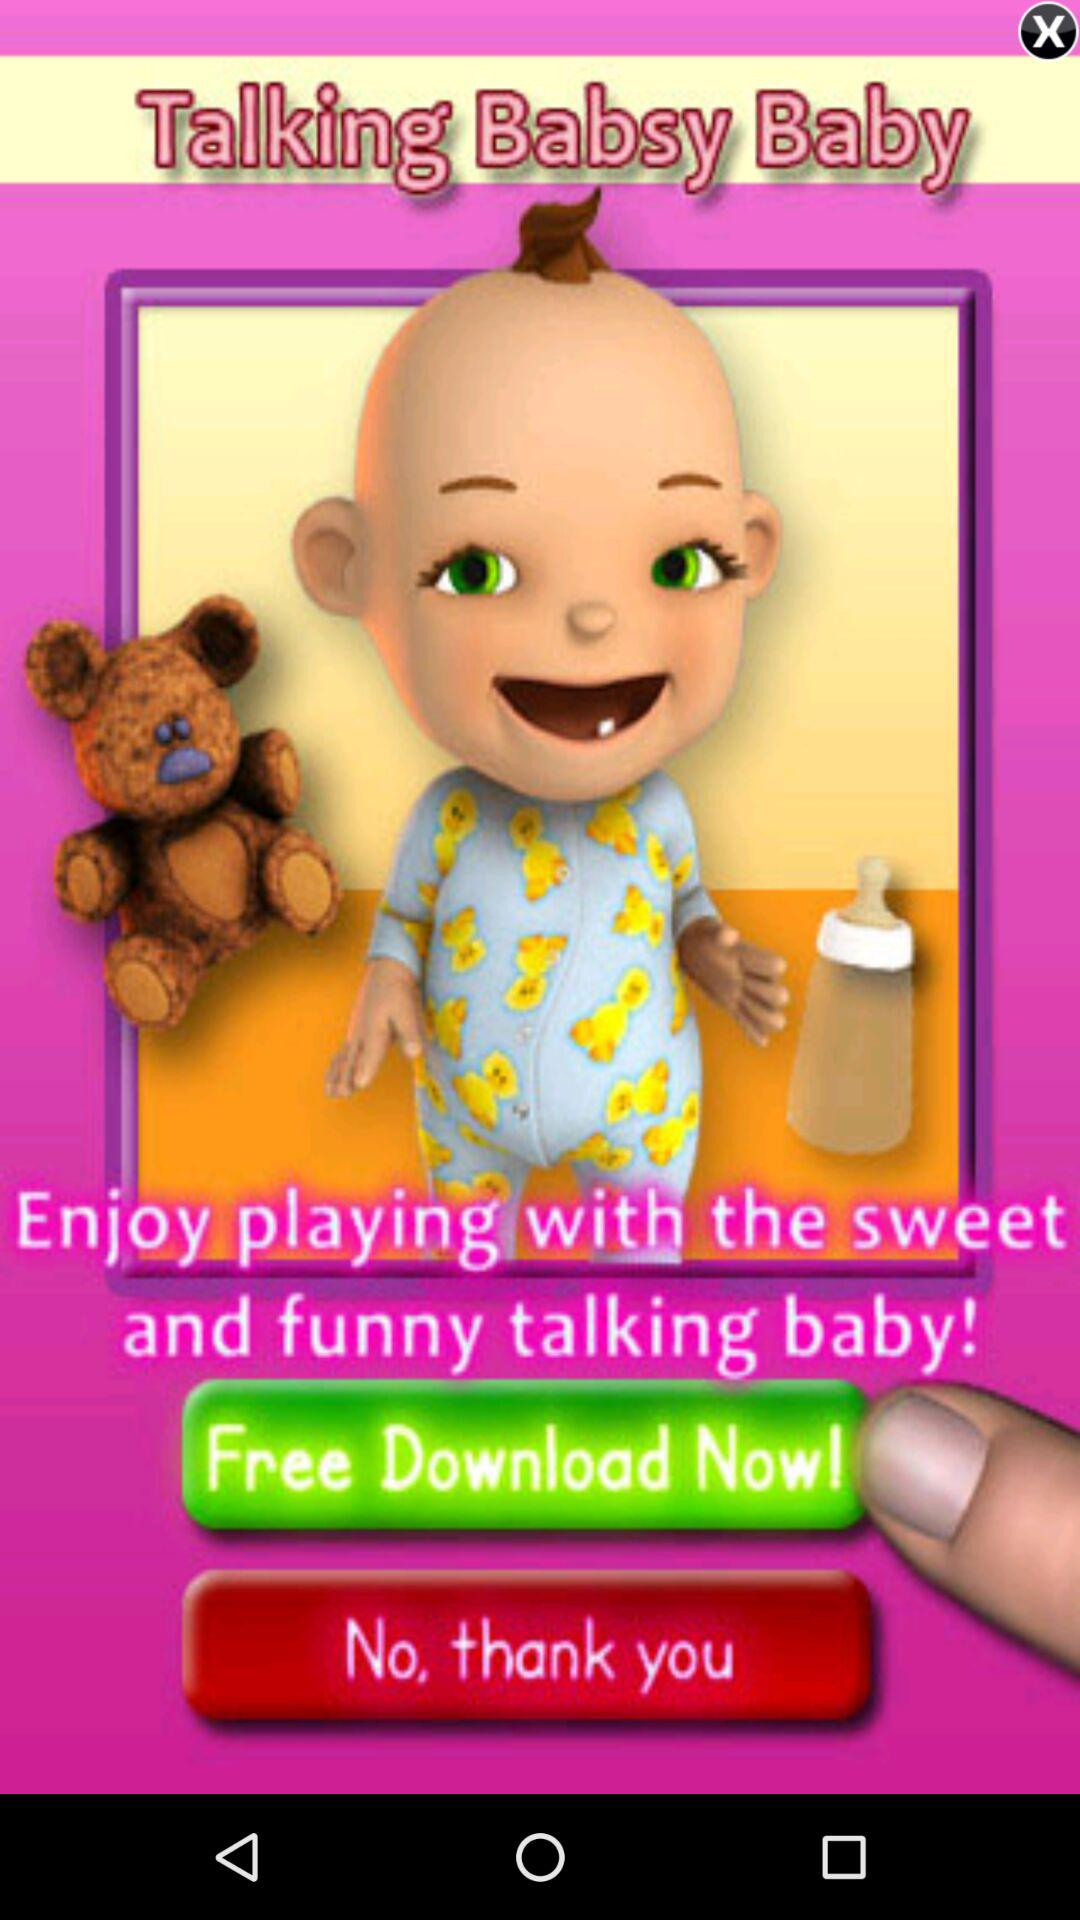What is the application name? The application name is "Talking Babsy Baby". 